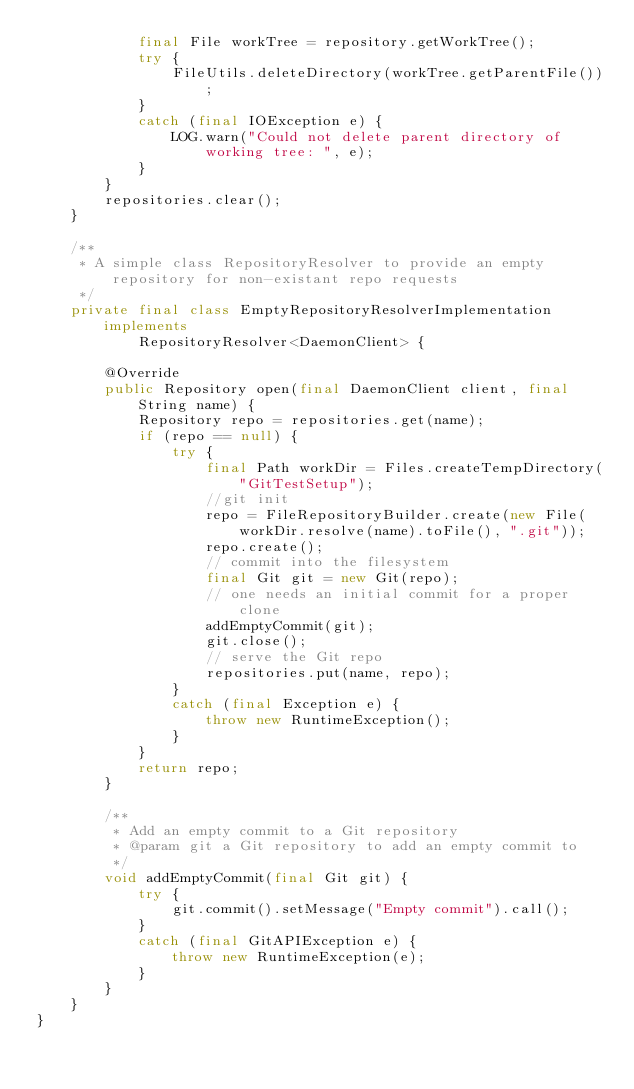Convert code to text. <code><loc_0><loc_0><loc_500><loc_500><_Java_>            final File workTree = repository.getWorkTree();
            try {
                FileUtils.deleteDirectory(workTree.getParentFile());
            }
            catch (final IOException e) {
                LOG.warn("Could not delete parent directory of working tree: ", e);
            }
        }
        repositories.clear();
    }

    /**
     * A simple class RepositoryResolver to provide an empty repository for non-existant repo requests
     */
    private final class EmptyRepositoryResolverImplementation implements
            RepositoryResolver<DaemonClient> {

        @Override
        public Repository open(final DaemonClient client, final String name) {
            Repository repo = repositories.get(name);
            if (repo == null) {
                try {
                    final Path workDir = Files.createTempDirectory("GitTestSetup");
                    //git init
                    repo = FileRepositoryBuilder.create(new File(workDir.resolve(name).toFile(), ".git"));
                    repo.create();
                    // commit into the filesystem
                    final Git git = new Git(repo);
                    // one needs an initial commit for a proper clone
                    addEmptyCommit(git);
                    git.close();
                    // serve the Git repo
                    repositories.put(name, repo);
                }
                catch (final Exception e) {
                    throw new RuntimeException();
                }
            }
            return repo;
        }

        /**
         * Add an empty commit to a Git repository
         * @param git a Git repository to add an empty commit to
         */
        void addEmptyCommit(final Git git) {
            try {
                git.commit().setMessage("Empty commit").call();
            }
            catch (final GitAPIException e) {
                throw new RuntimeException(e);
            }
        }
    }
}
</code> 